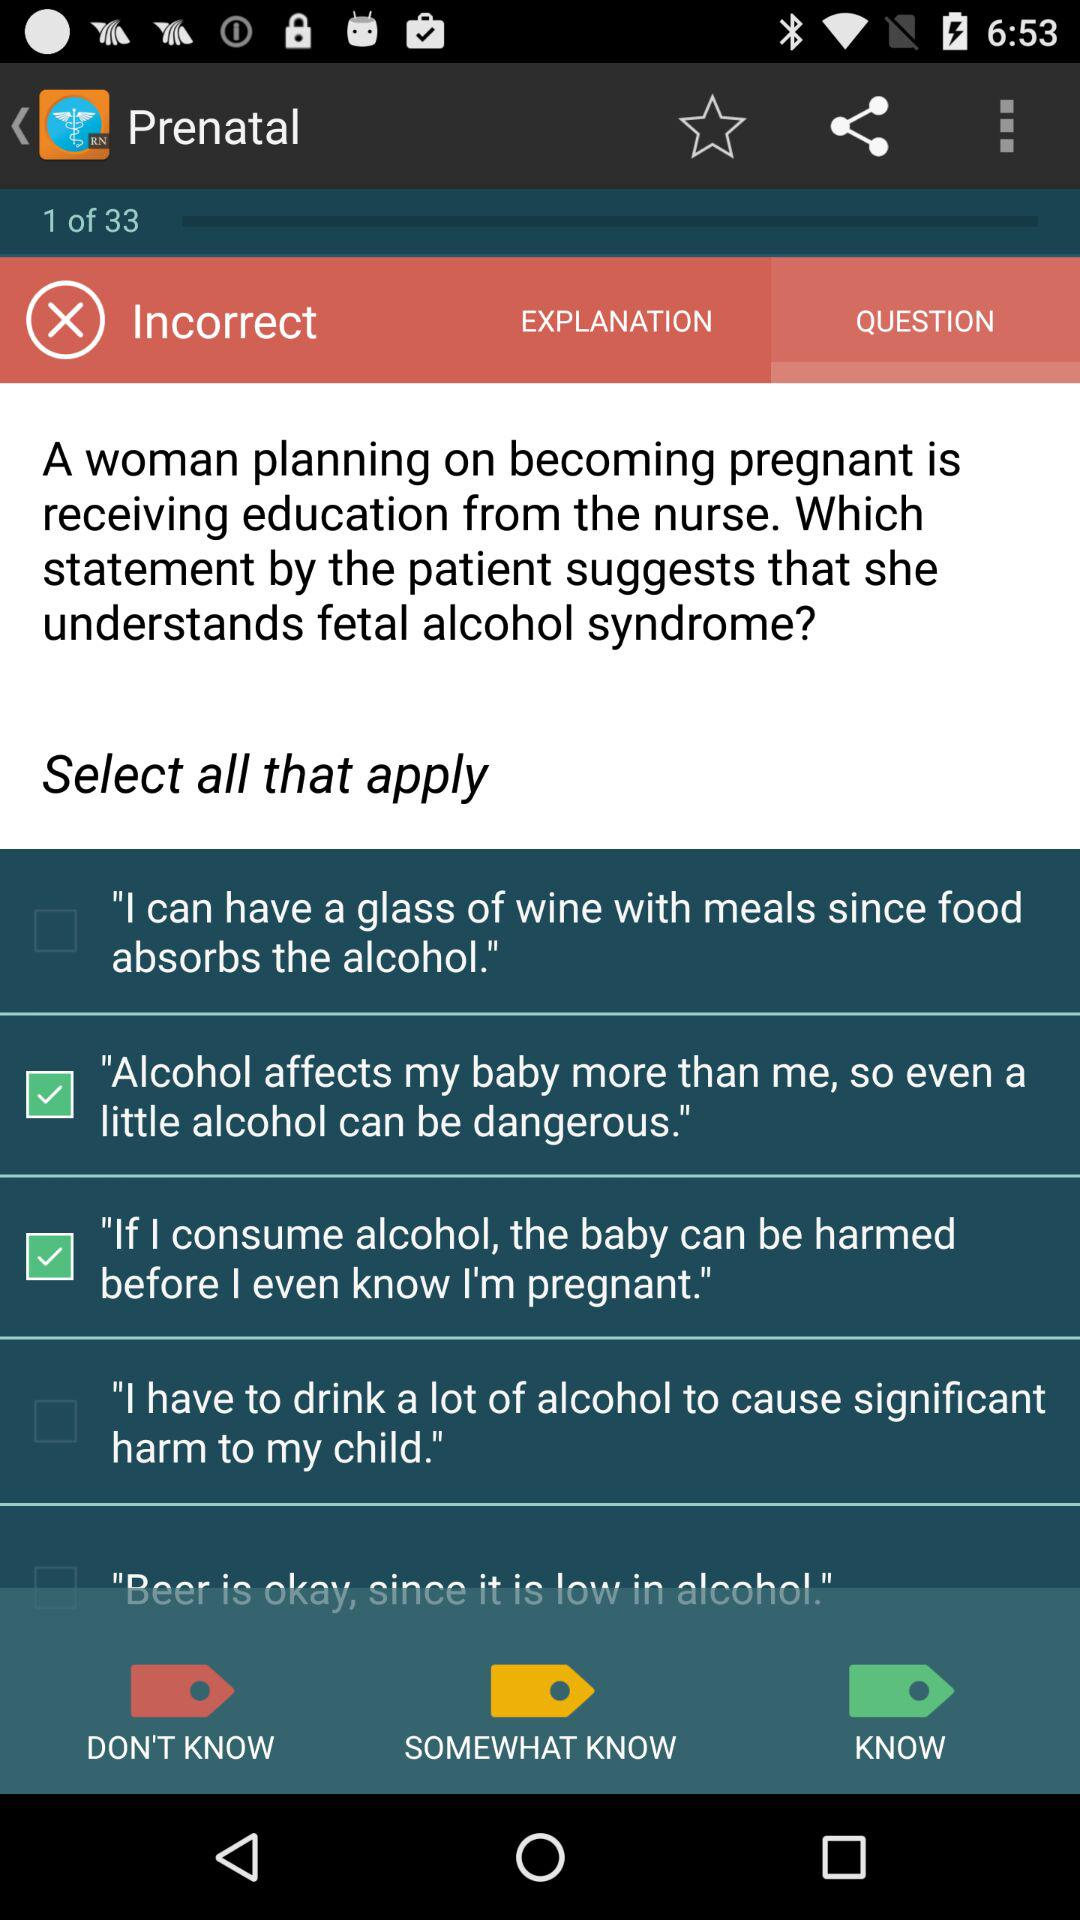Which options are selected? The options are "Alcohol affects my baby more than me, so even a little alcohol can be dangerous" and "If I consume alcohol, the baby can be harmed before I even know I'm pregnant". 